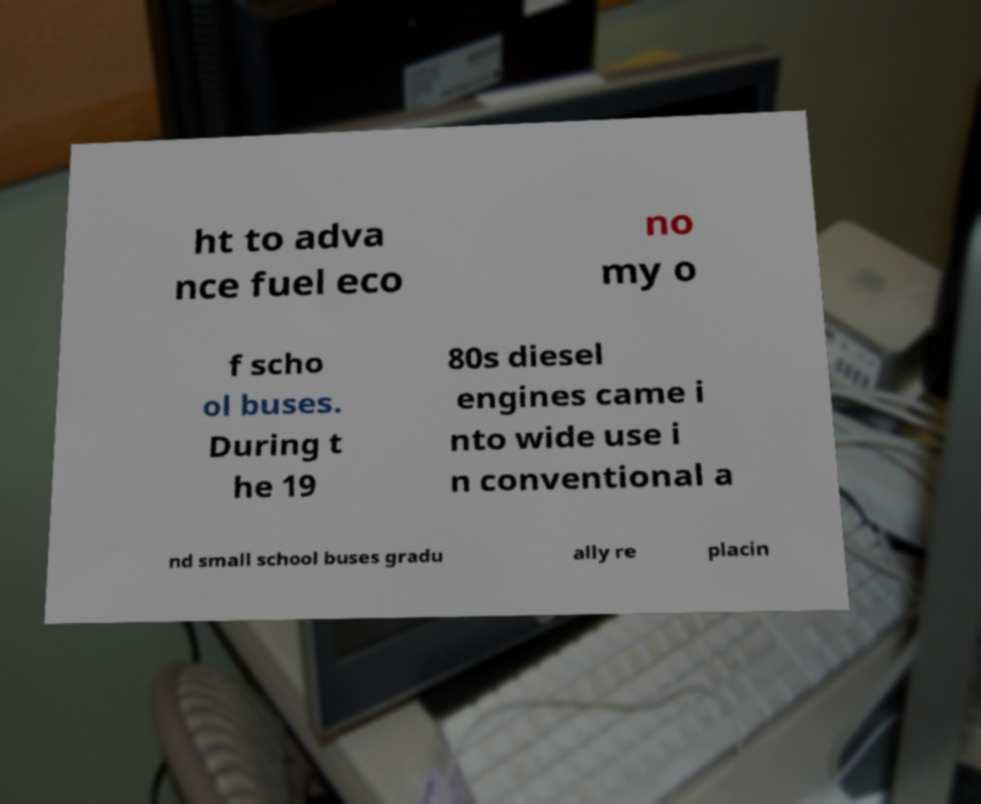What messages or text are displayed in this image? I need them in a readable, typed format. ht to adva nce fuel eco no my o f scho ol buses. During t he 19 80s diesel engines came i nto wide use i n conventional a nd small school buses gradu ally re placin 